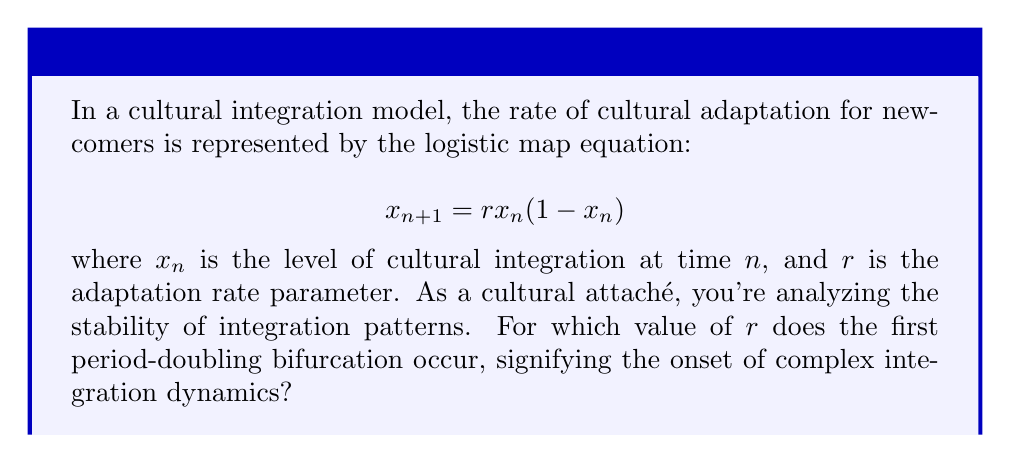Teach me how to tackle this problem. To solve this problem, we need to understand the behavior of the logistic map and its bifurcations:

1) The logistic map is stable for $0 < r < 3$.

2) As $r$ increases beyond 3, the system undergoes a series of period-doubling bifurcations.

3) The first bifurcation occurs when the fixed point becomes unstable and a 2-cycle appears.

4) To find this point, we need to solve the equation:

   $$\left|\frac{d}{dx}(rx(1-x))\right|_{x=x^*} = -1$$

   where $x^*$ is the non-zero fixed point of the map.

5) The non-zero fixed point is given by:

   $$x^* = 1 - \frac{1}{r}$$

6) Substituting this into the derivative equation:

   $$\left|r(1-2x^*)\right| = 1$$

7) Simplifying:

   $$\left|r(1-2(1-\frac{1}{r}))\right| = 1$$
   $$\left|r(-1+\frac{2}{r})\right| = 1$$
   $$\left|-r+2\right| = 1$$

8) Solving this equation:

   $-r+2 = 1$ or $-r+2 = -1$
   $r = 1$ or $r = 3$

9) Since we know the system is stable for $r < 3$, the first bifurcation occurs at $r = 3$.

This value of $r = 3$ marks the transition from stable integration to more complex patterns, which could represent the emergence of subcultures or resistance to full integration.
Answer: $r = 3$ 